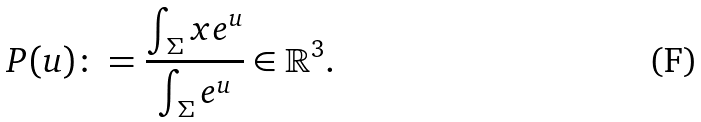Convert formula to latex. <formula><loc_0><loc_0><loc_500><loc_500>P ( u ) \colon = \frac { \int _ { \Sigma } x e ^ { u } } { \int _ { \Sigma } e ^ { u } } \in \mathbb { R } ^ { 3 } .</formula> 